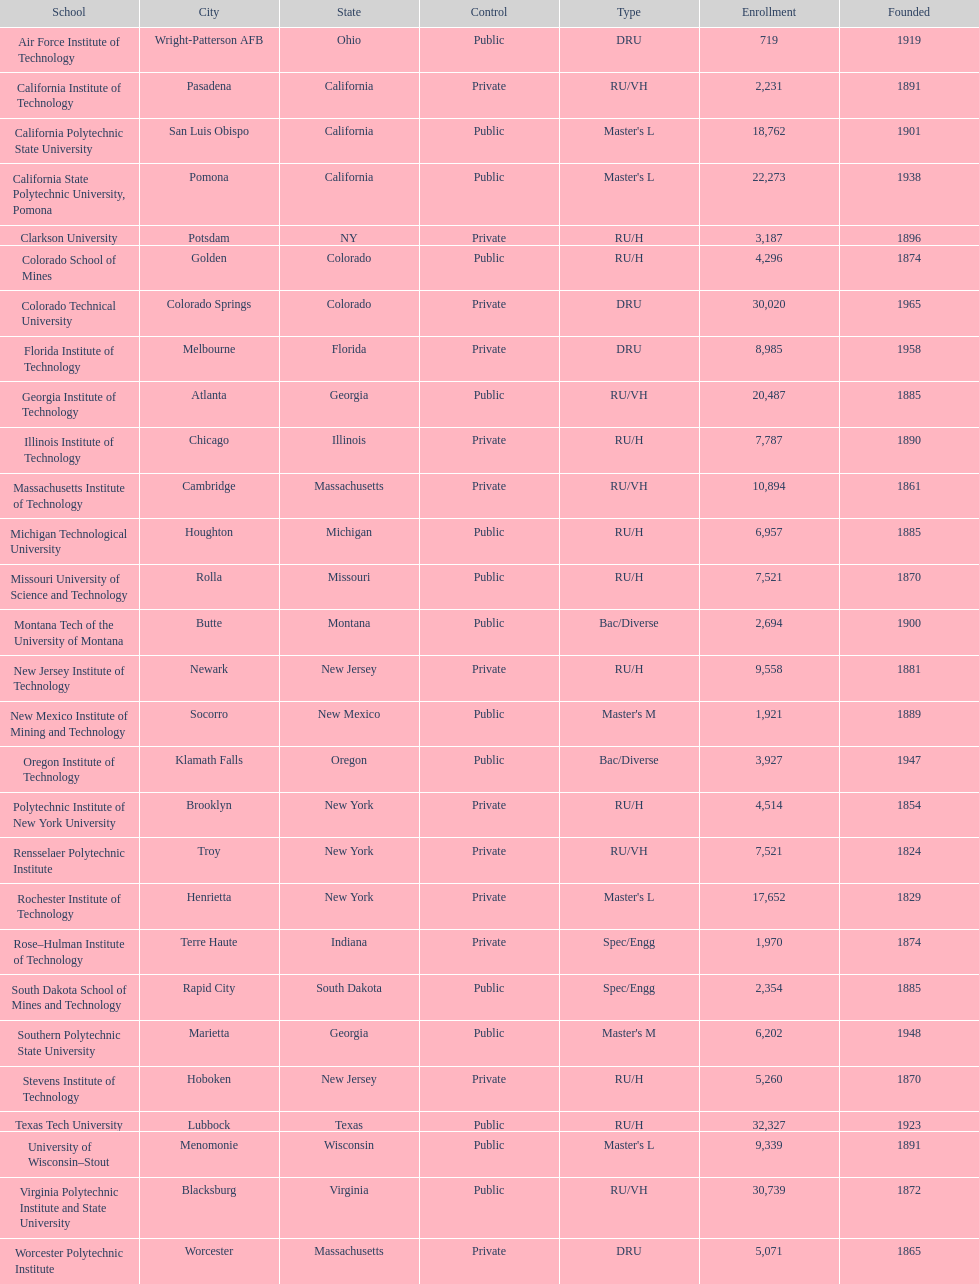What school is listed next after michigan technological university? Missouri University of Science and Technology. 